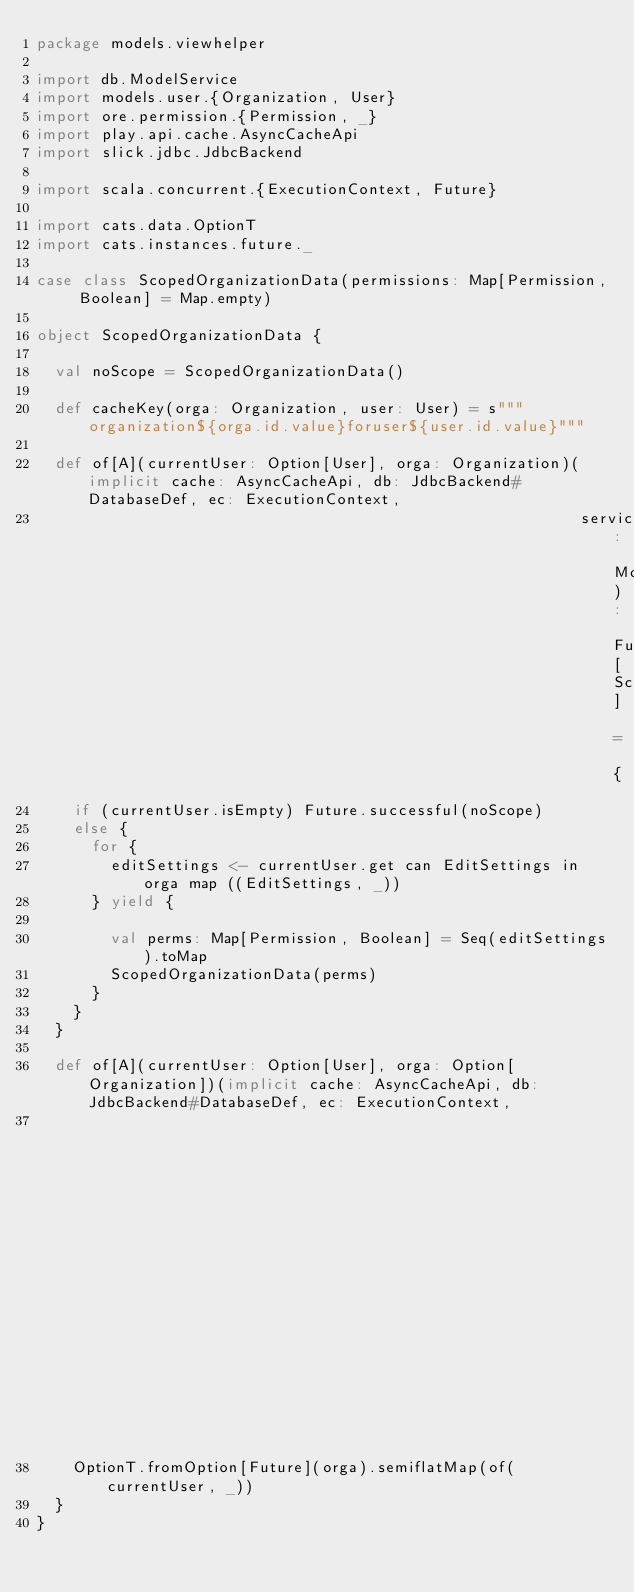Convert code to text. <code><loc_0><loc_0><loc_500><loc_500><_Scala_>package models.viewhelper

import db.ModelService
import models.user.{Organization, User}
import ore.permission.{Permission, _}
import play.api.cache.AsyncCacheApi
import slick.jdbc.JdbcBackend

import scala.concurrent.{ExecutionContext, Future}

import cats.data.OptionT
import cats.instances.future._

case class ScopedOrganizationData(permissions: Map[Permission, Boolean] = Map.empty)

object ScopedOrganizationData {

  val noScope = ScopedOrganizationData()

  def cacheKey(orga: Organization, user: User) = s"""organization${orga.id.value}foruser${user.id.value}"""

  def of[A](currentUser: Option[User], orga: Organization)(implicit cache: AsyncCacheApi, db: JdbcBackend#DatabaseDef, ec: ExecutionContext,
                                                           service: ModelService): Future[ScopedOrganizationData] = {
    if (currentUser.isEmpty) Future.successful(noScope)
    else {
      for {
        editSettings <- currentUser.get can EditSettings in orga map ((EditSettings, _))
      } yield {

        val perms: Map[Permission, Boolean] = Seq(editSettings).toMap
        ScopedOrganizationData(perms)
      }
    }
  }

  def of[A](currentUser: Option[User], orga: Option[Organization])(implicit cache: AsyncCacheApi, db: JdbcBackend#DatabaseDef, ec: ExecutionContext,
                                                                   service: ModelService): OptionT[Future, ScopedOrganizationData] = {
    OptionT.fromOption[Future](orga).semiflatMap(of(currentUser, _))
  }
}
</code> 